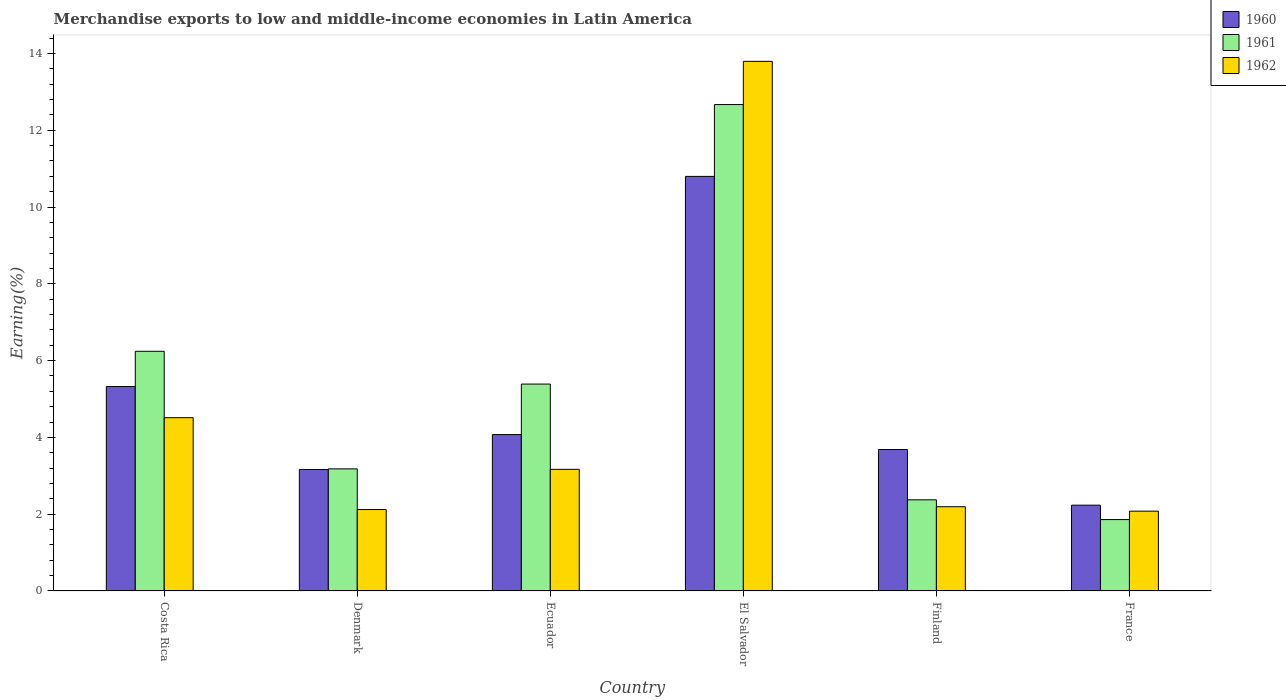How many different coloured bars are there?
Offer a very short reply. 3. How many bars are there on the 2nd tick from the right?
Give a very brief answer. 3. What is the label of the 2nd group of bars from the left?
Make the answer very short. Denmark. What is the percentage of amount earned from merchandise exports in 1961 in Ecuador?
Your answer should be compact. 5.39. Across all countries, what is the maximum percentage of amount earned from merchandise exports in 1960?
Your answer should be compact. 10.8. Across all countries, what is the minimum percentage of amount earned from merchandise exports in 1961?
Your answer should be compact. 1.86. In which country was the percentage of amount earned from merchandise exports in 1961 maximum?
Make the answer very short. El Salvador. What is the total percentage of amount earned from merchandise exports in 1961 in the graph?
Give a very brief answer. 31.71. What is the difference between the percentage of amount earned from merchandise exports in 1962 in Ecuador and that in El Salvador?
Make the answer very short. -10.63. What is the difference between the percentage of amount earned from merchandise exports in 1961 in Costa Rica and the percentage of amount earned from merchandise exports in 1960 in Finland?
Your answer should be compact. 2.56. What is the average percentage of amount earned from merchandise exports in 1960 per country?
Ensure brevity in your answer.  4.88. What is the difference between the percentage of amount earned from merchandise exports of/in 1960 and percentage of amount earned from merchandise exports of/in 1961 in Ecuador?
Your answer should be compact. -1.32. What is the ratio of the percentage of amount earned from merchandise exports in 1962 in Ecuador to that in Finland?
Offer a very short reply. 1.44. Is the percentage of amount earned from merchandise exports in 1962 in Denmark less than that in El Salvador?
Your response must be concise. Yes. Is the difference between the percentage of amount earned from merchandise exports in 1960 in Denmark and Ecuador greater than the difference between the percentage of amount earned from merchandise exports in 1961 in Denmark and Ecuador?
Offer a terse response. Yes. What is the difference between the highest and the second highest percentage of amount earned from merchandise exports in 1961?
Give a very brief answer. 7.28. What is the difference between the highest and the lowest percentage of amount earned from merchandise exports in 1962?
Your answer should be compact. 11.71. What does the 1st bar from the left in Costa Rica represents?
Keep it short and to the point. 1960. Is it the case that in every country, the sum of the percentage of amount earned from merchandise exports in 1960 and percentage of amount earned from merchandise exports in 1962 is greater than the percentage of amount earned from merchandise exports in 1961?
Your response must be concise. Yes. Are all the bars in the graph horizontal?
Provide a succinct answer. No. What is the difference between two consecutive major ticks on the Y-axis?
Offer a very short reply. 2. Are the values on the major ticks of Y-axis written in scientific E-notation?
Your answer should be compact. No. Does the graph contain grids?
Give a very brief answer. No. Where does the legend appear in the graph?
Your answer should be compact. Top right. How are the legend labels stacked?
Make the answer very short. Vertical. What is the title of the graph?
Your response must be concise. Merchandise exports to low and middle-income economies in Latin America. Does "1962" appear as one of the legend labels in the graph?
Provide a succinct answer. Yes. What is the label or title of the Y-axis?
Provide a succinct answer. Earning(%). What is the Earning(%) of 1960 in Costa Rica?
Keep it short and to the point. 5.32. What is the Earning(%) in 1961 in Costa Rica?
Your answer should be compact. 6.24. What is the Earning(%) in 1962 in Costa Rica?
Your response must be concise. 4.51. What is the Earning(%) in 1960 in Denmark?
Give a very brief answer. 3.16. What is the Earning(%) of 1961 in Denmark?
Provide a short and direct response. 3.18. What is the Earning(%) in 1962 in Denmark?
Keep it short and to the point. 2.12. What is the Earning(%) of 1960 in Ecuador?
Keep it short and to the point. 4.07. What is the Earning(%) in 1961 in Ecuador?
Offer a very short reply. 5.39. What is the Earning(%) of 1962 in Ecuador?
Ensure brevity in your answer.  3.17. What is the Earning(%) in 1960 in El Salvador?
Your answer should be compact. 10.8. What is the Earning(%) in 1961 in El Salvador?
Keep it short and to the point. 12.67. What is the Earning(%) in 1962 in El Salvador?
Offer a very short reply. 13.79. What is the Earning(%) in 1960 in Finland?
Your response must be concise. 3.68. What is the Earning(%) in 1961 in Finland?
Provide a short and direct response. 2.37. What is the Earning(%) in 1962 in Finland?
Offer a terse response. 2.19. What is the Earning(%) in 1960 in France?
Offer a terse response. 2.23. What is the Earning(%) in 1961 in France?
Ensure brevity in your answer.  1.86. What is the Earning(%) of 1962 in France?
Ensure brevity in your answer.  2.08. Across all countries, what is the maximum Earning(%) of 1960?
Keep it short and to the point. 10.8. Across all countries, what is the maximum Earning(%) in 1961?
Offer a terse response. 12.67. Across all countries, what is the maximum Earning(%) of 1962?
Ensure brevity in your answer.  13.79. Across all countries, what is the minimum Earning(%) in 1960?
Offer a terse response. 2.23. Across all countries, what is the minimum Earning(%) in 1961?
Your answer should be very brief. 1.86. Across all countries, what is the minimum Earning(%) in 1962?
Give a very brief answer. 2.08. What is the total Earning(%) in 1960 in the graph?
Your answer should be compact. 29.28. What is the total Earning(%) in 1961 in the graph?
Provide a succinct answer. 31.71. What is the total Earning(%) in 1962 in the graph?
Make the answer very short. 27.87. What is the difference between the Earning(%) of 1960 in Costa Rica and that in Denmark?
Your response must be concise. 2.16. What is the difference between the Earning(%) in 1961 in Costa Rica and that in Denmark?
Provide a succinct answer. 3.06. What is the difference between the Earning(%) of 1962 in Costa Rica and that in Denmark?
Provide a succinct answer. 2.39. What is the difference between the Earning(%) in 1960 in Costa Rica and that in Ecuador?
Your answer should be compact. 1.25. What is the difference between the Earning(%) of 1961 in Costa Rica and that in Ecuador?
Give a very brief answer. 0.85. What is the difference between the Earning(%) of 1962 in Costa Rica and that in Ecuador?
Make the answer very short. 1.35. What is the difference between the Earning(%) of 1960 in Costa Rica and that in El Salvador?
Offer a terse response. -5.47. What is the difference between the Earning(%) in 1961 in Costa Rica and that in El Salvador?
Give a very brief answer. -6.43. What is the difference between the Earning(%) of 1962 in Costa Rica and that in El Salvador?
Provide a short and direct response. -9.28. What is the difference between the Earning(%) of 1960 in Costa Rica and that in Finland?
Make the answer very short. 1.64. What is the difference between the Earning(%) of 1961 in Costa Rica and that in Finland?
Provide a short and direct response. 3.87. What is the difference between the Earning(%) of 1962 in Costa Rica and that in Finland?
Offer a very short reply. 2.32. What is the difference between the Earning(%) in 1960 in Costa Rica and that in France?
Offer a terse response. 3.09. What is the difference between the Earning(%) in 1961 in Costa Rica and that in France?
Your answer should be very brief. 4.38. What is the difference between the Earning(%) of 1962 in Costa Rica and that in France?
Ensure brevity in your answer.  2.43. What is the difference between the Earning(%) in 1960 in Denmark and that in Ecuador?
Your response must be concise. -0.91. What is the difference between the Earning(%) of 1961 in Denmark and that in Ecuador?
Your answer should be compact. -2.21. What is the difference between the Earning(%) of 1962 in Denmark and that in Ecuador?
Your answer should be compact. -1.05. What is the difference between the Earning(%) in 1960 in Denmark and that in El Salvador?
Your answer should be compact. -7.63. What is the difference between the Earning(%) of 1961 in Denmark and that in El Salvador?
Keep it short and to the point. -9.49. What is the difference between the Earning(%) in 1962 in Denmark and that in El Salvador?
Offer a terse response. -11.67. What is the difference between the Earning(%) in 1960 in Denmark and that in Finland?
Make the answer very short. -0.52. What is the difference between the Earning(%) of 1961 in Denmark and that in Finland?
Offer a very short reply. 0.81. What is the difference between the Earning(%) of 1962 in Denmark and that in Finland?
Keep it short and to the point. -0.07. What is the difference between the Earning(%) of 1960 in Denmark and that in France?
Offer a very short reply. 0.93. What is the difference between the Earning(%) of 1961 in Denmark and that in France?
Your answer should be compact. 1.32. What is the difference between the Earning(%) in 1962 in Denmark and that in France?
Ensure brevity in your answer.  0.04. What is the difference between the Earning(%) of 1960 in Ecuador and that in El Salvador?
Your answer should be compact. -6.72. What is the difference between the Earning(%) in 1961 in Ecuador and that in El Salvador?
Offer a very short reply. -7.28. What is the difference between the Earning(%) in 1962 in Ecuador and that in El Salvador?
Give a very brief answer. -10.63. What is the difference between the Earning(%) of 1960 in Ecuador and that in Finland?
Ensure brevity in your answer.  0.39. What is the difference between the Earning(%) in 1961 in Ecuador and that in Finland?
Your answer should be compact. 3.01. What is the difference between the Earning(%) of 1962 in Ecuador and that in Finland?
Offer a terse response. 0.97. What is the difference between the Earning(%) in 1960 in Ecuador and that in France?
Give a very brief answer. 1.84. What is the difference between the Earning(%) of 1961 in Ecuador and that in France?
Offer a very short reply. 3.53. What is the difference between the Earning(%) of 1962 in Ecuador and that in France?
Make the answer very short. 1.09. What is the difference between the Earning(%) of 1960 in El Salvador and that in Finland?
Keep it short and to the point. 7.11. What is the difference between the Earning(%) in 1961 in El Salvador and that in Finland?
Your response must be concise. 10.29. What is the difference between the Earning(%) of 1962 in El Salvador and that in Finland?
Give a very brief answer. 11.6. What is the difference between the Earning(%) of 1960 in El Salvador and that in France?
Provide a succinct answer. 8.56. What is the difference between the Earning(%) in 1961 in El Salvador and that in France?
Your answer should be compact. 10.81. What is the difference between the Earning(%) in 1962 in El Salvador and that in France?
Keep it short and to the point. 11.71. What is the difference between the Earning(%) of 1960 in Finland and that in France?
Your answer should be very brief. 1.45. What is the difference between the Earning(%) in 1961 in Finland and that in France?
Your answer should be compact. 0.51. What is the difference between the Earning(%) in 1962 in Finland and that in France?
Offer a very short reply. 0.12. What is the difference between the Earning(%) in 1960 in Costa Rica and the Earning(%) in 1961 in Denmark?
Give a very brief answer. 2.14. What is the difference between the Earning(%) in 1960 in Costa Rica and the Earning(%) in 1962 in Denmark?
Offer a terse response. 3.2. What is the difference between the Earning(%) of 1961 in Costa Rica and the Earning(%) of 1962 in Denmark?
Give a very brief answer. 4.12. What is the difference between the Earning(%) of 1960 in Costa Rica and the Earning(%) of 1961 in Ecuador?
Your answer should be very brief. -0.06. What is the difference between the Earning(%) in 1960 in Costa Rica and the Earning(%) in 1962 in Ecuador?
Your answer should be compact. 2.16. What is the difference between the Earning(%) in 1961 in Costa Rica and the Earning(%) in 1962 in Ecuador?
Offer a terse response. 3.07. What is the difference between the Earning(%) of 1960 in Costa Rica and the Earning(%) of 1961 in El Salvador?
Make the answer very short. -7.34. What is the difference between the Earning(%) in 1960 in Costa Rica and the Earning(%) in 1962 in El Salvador?
Give a very brief answer. -8.47. What is the difference between the Earning(%) in 1961 in Costa Rica and the Earning(%) in 1962 in El Salvador?
Give a very brief answer. -7.55. What is the difference between the Earning(%) of 1960 in Costa Rica and the Earning(%) of 1961 in Finland?
Give a very brief answer. 2.95. What is the difference between the Earning(%) of 1960 in Costa Rica and the Earning(%) of 1962 in Finland?
Provide a succinct answer. 3.13. What is the difference between the Earning(%) in 1961 in Costa Rica and the Earning(%) in 1962 in Finland?
Your answer should be compact. 4.05. What is the difference between the Earning(%) in 1960 in Costa Rica and the Earning(%) in 1961 in France?
Give a very brief answer. 3.46. What is the difference between the Earning(%) of 1960 in Costa Rica and the Earning(%) of 1962 in France?
Your answer should be very brief. 3.25. What is the difference between the Earning(%) in 1961 in Costa Rica and the Earning(%) in 1962 in France?
Your response must be concise. 4.16. What is the difference between the Earning(%) in 1960 in Denmark and the Earning(%) in 1961 in Ecuador?
Ensure brevity in your answer.  -2.22. What is the difference between the Earning(%) of 1960 in Denmark and the Earning(%) of 1962 in Ecuador?
Offer a very short reply. -0. What is the difference between the Earning(%) of 1961 in Denmark and the Earning(%) of 1962 in Ecuador?
Your response must be concise. 0.01. What is the difference between the Earning(%) in 1960 in Denmark and the Earning(%) in 1961 in El Salvador?
Give a very brief answer. -9.5. What is the difference between the Earning(%) of 1960 in Denmark and the Earning(%) of 1962 in El Salvador?
Keep it short and to the point. -10.63. What is the difference between the Earning(%) of 1961 in Denmark and the Earning(%) of 1962 in El Salvador?
Keep it short and to the point. -10.61. What is the difference between the Earning(%) in 1960 in Denmark and the Earning(%) in 1961 in Finland?
Give a very brief answer. 0.79. What is the difference between the Earning(%) in 1960 in Denmark and the Earning(%) in 1962 in Finland?
Your answer should be compact. 0.97. What is the difference between the Earning(%) of 1961 in Denmark and the Earning(%) of 1962 in Finland?
Provide a succinct answer. 0.99. What is the difference between the Earning(%) in 1960 in Denmark and the Earning(%) in 1961 in France?
Provide a succinct answer. 1.3. What is the difference between the Earning(%) of 1960 in Denmark and the Earning(%) of 1962 in France?
Make the answer very short. 1.09. What is the difference between the Earning(%) in 1961 in Denmark and the Earning(%) in 1962 in France?
Your answer should be very brief. 1.1. What is the difference between the Earning(%) in 1960 in Ecuador and the Earning(%) in 1961 in El Salvador?
Your answer should be compact. -8.59. What is the difference between the Earning(%) of 1960 in Ecuador and the Earning(%) of 1962 in El Salvador?
Offer a very short reply. -9.72. What is the difference between the Earning(%) in 1961 in Ecuador and the Earning(%) in 1962 in El Salvador?
Provide a succinct answer. -8.4. What is the difference between the Earning(%) in 1960 in Ecuador and the Earning(%) in 1961 in Finland?
Give a very brief answer. 1.7. What is the difference between the Earning(%) of 1960 in Ecuador and the Earning(%) of 1962 in Finland?
Ensure brevity in your answer.  1.88. What is the difference between the Earning(%) in 1961 in Ecuador and the Earning(%) in 1962 in Finland?
Keep it short and to the point. 3.19. What is the difference between the Earning(%) in 1960 in Ecuador and the Earning(%) in 1961 in France?
Provide a succinct answer. 2.21. What is the difference between the Earning(%) in 1960 in Ecuador and the Earning(%) in 1962 in France?
Make the answer very short. 1.99. What is the difference between the Earning(%) in 1961 in Ecuador and the Earning(%) in 1962 in France?
Provide a succinct answer. 3.31. What is the difference between the Earning(%) in 1960 in El Salvador and the Earning(%) in 1961 in Finland?
Your response must be concise. 8.42. What is the difference between the Earning(%) in 1960 in El Salvador and the Earning(%) in 1962 in Finland?
Provide a short and direct response. 8.6. What is the difference between the Earning(%) of 1961 in El Salvador and the Earning(%) of 1962 in Finland?
Offer a terse response. 10.47. What is the difference between the Earning(%) of 1960 in El Salvador and the Earning(%) of 1961 in France?
Your answer should be compact. 8.94. What is the difference between the Earning(%) in 1960 in El Salvador and the Earning(%) in 1962 in France?
Your answer should be compact. 8.72. What is the difference between the Earning(%) of 1961 in El Salvador and the Earning(%) of 1962 in France?
Provide a short and direct response. 10.59. What is the difference between the Earning(%) in 1960 in Finland and the Earning(%) in 1961 in France?
Make the answer very short. 1.82. What is the difference between the Earning(%) of 1960 in Finland and the Earning(%) of 1962 in France?
Keep it short and to the point. 1.6. What is the difference between the Earning(%) in 1961 in Finland and the Earning(%) in 1962 in France?
Your answer should be compact. 0.3. What is the average Earning(%) in 1960 per country?
Provide a short and direct response. 4.88. What is the average Earning(%) in 1961 per country?
Offer a very short reply. 5.29. What is the average Earning(%) of 1962 per country?
Offer a terse response. 4.64. What is the difference between the Earning(%) in 1960 and Earning(%) in 1961 in Costa Rica?
Make the answer very short. -0.92. What is the difference between the Earning(%) of 1960 and Earning(%) of 1962 in Costa Rica?
Give a very brief answer. 0.81. What is the difference between the Earning(%) of 1961 and Earning(%) of 1962 in Costa Rica?
Your answer should be very brief. 1.73. What is the difference between the Earning(%) in 1960 and Earning(%) in 1961 in Denmark?
Ensure brevity in your answer.  -0.02. What is the difference between the Earning(%) in 1960 and Earning(%) in 1962 in Denmark?
Offer a very short reply. 1.04. What is the difference between the Earning(%) in 1961 and Earning(%) in 1962 in Denmark?
Make the answer very short. 1.06. What is the difference between the Earning(%) in 1960 and Earning(%) in 1961 in Ecuador?
Your answer should be very brief. -1.32. What is the difference between the Earning(%) in 1960 and Earning(%) in 1962 in Ecuador?
Provide a short and direct response. 0.91. What is the difference between the Earning(%) in 1961 and Earning(%) in 1962 in Ecuador?
Offer a terse response. 2.22. What is the difference between the Earning(%) of 1960 and Earning(%) of 1961 in El Salvador?
Provide a succinct answer. -1.87. What is the difference between the Earning(%) in 1960 and Earning(%) in 1962 in El Salvador?
Provide a succinct answer. -3. What is the difference between the Earning(%) of 1961 and Earning(%) of 1962 in El Salvador?
Keep it short and to the point. -1.13. What is the difference between the Earning(%) in 1960 and Earning(%) in 1961 in Finland?
Provide a short and direct response. 1.31. What is the difference between the Earning(%) of 1960 and Earning(%) of 1962 in Finland?
Your answer should be compact. 1.49. What is the difference between the Earning(%) of 1961 and Earning(%) of 1962 in Finland?
Your answer should be very brief. 0.18. What is the difference between the Earning(%) in 1960 and Earning(%) in 1961 in France?
Provide a short and direct response. 0.38. What is the difference between the Earning(%) in 1960 and Earning(%) in 1962 in France?
Give a very brief answer. 0.16. What is the difference between the Earning(%) in 1961 and Earning(%) in 1962 in France?
Keep it short and to the point. -0.22. What is the ratio of the Earning(%) of 1960 in Costa Rica to that in Denmark?
Offer a very short reply. 1.68. What is the ratio of the Earning(%) of 1961 in Costa Rica to that in Denmark?
Ensure brevity in your answer.  1.96. What is the ratio of the Earning(%) in 1962 in Costa Rica to that in Denmark?
Make the answer very short. 2.13. What is the ratio of the Earning(%) in 1960 in Costa Rica to that in Ecuador?
Provide a short and direct response. 1.31. What is the ratio of the Earning(%) in 1961 in Costa Rica to that in Ecuador?
Provide a succinct answer. 1.16. What is the ratio of the Earning(%) in 1962 in Costa Rica to that in Ecuador?
Offer a very short reply. 1.42. What is the ratio of the Earning(%) in 1960 in Costa Rica to that in El Salvador?
Provide a short and direct response. 0.49. What is the ratio of the Earning(%) in 1961 in Costa Rica to that in El Salvador?
Provide a succinct answer. 0.49. What is the ratio of the Earning(%) of 1962 in Costa Rica to that in El Salvador?
Your answer should be compact. 0.33. What is the ratio of the Earning(%) in 1960 in Costa Rica to that in Finland?
Your answer should be compact. 1.45. What is the ratio of the Earning(%) in 1961 in Costa Rica to that in Finland?
Your answer should be very brief. 2.63. What is the ratio of the Earning(%) of 1962 in Costa Rica to that in Finland?
Provide a short and direct response. 2.06. What is the ratio of the Earning(%) in 1960 in Costa Rica to that in France?
Make the answer very short. 2.38. What is the ratio of the Earning(%) in 1961 in Costa Rica to that in France?
Offer a very short reply. 3.36. What is the ratio of the Earning(%) in 1962 in Costa Rica to that in France?
Your answer should be compact. 2.17. What is the ratio of the Earning(%) of 1960 in Denmark to that in Ecuador?
Offer a terse response. 0.78. What is the ratio of the Earning(%) of 1961 in Denmark to that in Ecuador?
Provide a succinct answer. 0.59. What is the ratio of the Earning(%) in 1962 in Denmark to that in Ecuador?
Keep it short and to the point. 0.67. What is the ratio of the Earning(%) of 1960 in Denmark to that in El Salvador?
Provide a succinct answer. 0.29. What is the ratio of the Earning(%) in 1961 in Denmark to that in El Salvador?
Provide a short and direct response. 0.25. What is the ratio of the Earning(%) in 1962 in Denmark to that in El Salvador?
Ensure brevity in your answer.  0.15. What is the ratio of the Earning(%) of 1960 in Denmark to that in Finland?
Your response must be concise. 0.86. What is the ratio of the Earning(%) of 1961 in Denmark to that in Finland?
Give a very brief answer. 1.34. What is the ratio of the Earning(%) in 1962 in Denmark to that in Finland?
Keep it short and to the point. 0.97. What is the ratio of the Earning(%) in 1960 in Denmark to that in France?
Keep it short and to the point. 1.42. What is the ratio of the Earning(%) of 1961 in Denmark to that in France?
Make the answer very short. 1.71. What is the ratio of the Earning(%) of 1960 in Ecuador to that in El Salvador?
Make the answer very short. 0.38. What is the ratio of the Earning(%) in 1961 in Ecuador to that in El Salvador?
Keep it short and to the point. 0.43. What is the ratio of the Earning(%) of 1962 in Ecuador to that in El Salvador?
Ensure brevity in your answer.  0.23. What is the ratio of the Earning(%) in 1960 in Ecuador to that in Finland?
Offer a terse response. 1.11. What is the ratio of the Earning(%) in 1961 in Ecuador to that in Finland?
Give a very brief answer. 2.27. What is the ratio of the Earning(%) of 1962 in Ecuador to that in Finland?
Provide a short and direct response. 1.44. What is the ratio of the Earning(%) of 1960 in Ecuador to that in France?
Offer a very short reply. 1.82. What is the ratio of the Earning(%) in 1961 in Ecuador to that in France?
Provide a succinct answer. 2.9. What is the ratio of the Earning(%) in 1962 in Ecuador to that in France?
Offer a terse response. 1.52. What is the ratio of the Earning(%) in 1960 in El Salvador to that in Finland?
Provide a succinct answer. 2.93. What is the ratio of the Earning(%) in 1961 in El Salvador to that in Finland?
Keep it short and to the point. 5.34. What is the ratio of the Earning(%) in 1962 in El Salvador to that in Finland?
Your response must be concise. 6.29. What is the ratio of the Earning(%) in 1960 in El Salvador to that in France?
Ensure brevity in your answer.  4.83. What is the ratio of the Earning(%) of 1961 in El Salvador to that in France?
Provide a short and direct response. 6.81. What is the ratio of the Earning(%) in 1962 in El Salvador to that in France?
Offer a very short reply. 6.63. What is the ratio of the Earning(%) in 1960 in Finland to that in France?
Provide a succinct answer. 1.65. What is the ratio of the Earning(%) of 1961 in Finland to that in France?
Offer a terse response. 1.28. What is the ratio of the Earning(%) in 1962 in Finland to that in France?
Give a very brief answer. 1.06. What is the difference between the highest and the second highest Earning(%) in 1960?
Provide a short and direct response. 5.47. What is the difference between the highest and the second highest Earning(%) in 1961?
Ensure brevity in your answer.  6.43. What is the difference between the highest and the second highest Earning(%) in 1962?
Make the answer very short. 9.28. What is the difference between the highest and the lowest Earning(%) of 1960?
Make the answer very short. 8.56. What is the difference between the highest and the lowest Earning(%) in 1961?
Provide a succinct answer. 10.81. What is the difference between the highest and the lowest Earning(%) in 1962?
Make the answer very short. 11.71. 